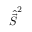Convert formula to latex. <formula><loc_0><loc_0><loc_500><loc_500>\hat { \vec { S } } ^ { 2 }</formula> 